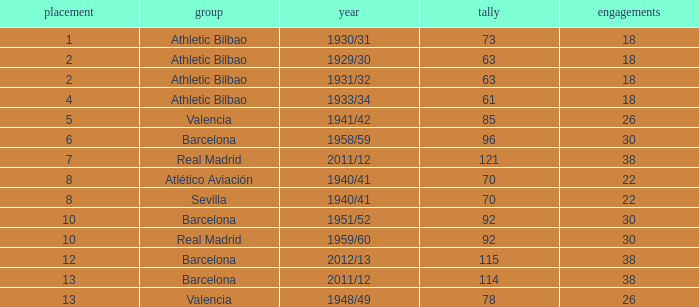How many apps when the rank was after 13 and having more than 73 goals? None. 